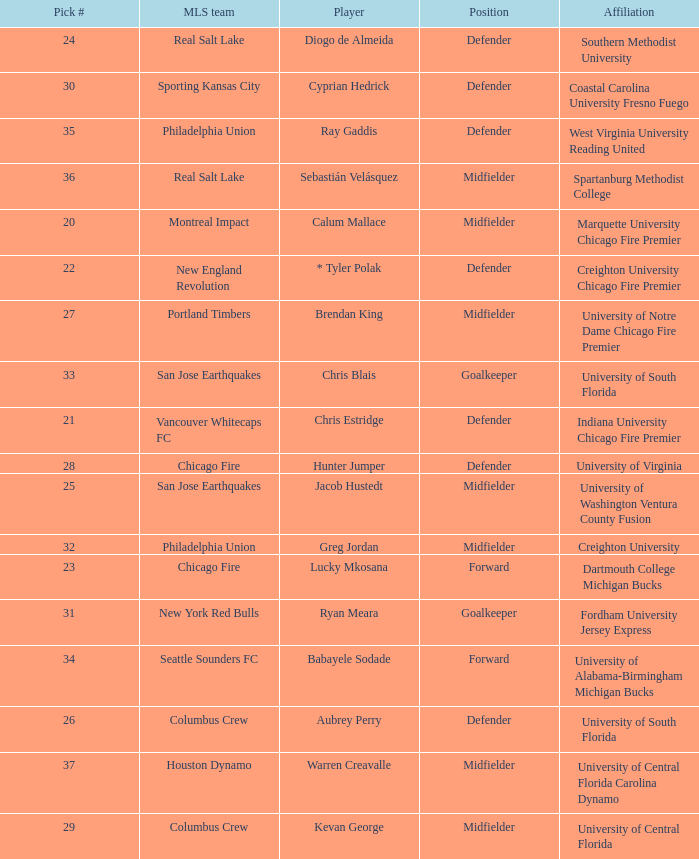What pick number did Real Salt Lake get? 24.0. Would you mind parsing the complete table? {'header': ['Pick #', 'MLS team', 'Player', 'Position', 'Affiliation'], 'rows': [['24', 'Real Salt Lake', 'Diogo de Almeida', 'Defender', 'Southern Methodist University'], ['30', 'Sporting Kansas City', 'Cyprian Hedrick', 'Defender', 'Coastal Carolina University Fresno Fuego'], ['35', 'Philadelphia Union', 'Ray Gaddis', 'Defender', 'West Virginia University Reading United'], ['36', 'Real Salt Lake', 'Sebastián Velásquez', 'Midfielder', 'Spartanburg Methodist College'], ['20', 'Montreal Impact', 'Calum Mallace', 'Midfielder', 'Marquette University Chicago Fire Premier'], ['22', 'New England Revolution', '* Tyler Polak', 'Defender', 'Creighton University Chicago Fire Premier'], ['27', 'Portland Timbers', 'Brendan King', 'Midfielder', 'University of Notre Dame Chicago Fire Premier'], ['33', 'San Jose Earthquakes', 'Chris Blais', 'Goalkeeper', 'University of South Florida'], ['21', 'Vancouver Whitecaps FC', 'Chris Estridge', 'Defender', 'Indiana University Chicago Fire Premier'], ['28', 'Chicago Fire', 'Hunter Jumper', 'Defender', 'University of Virginia'], ['25', 'San Jose Earthquakes', 'Jacob Hustedt', 'Midfielder', 'University of Washington Ventura County Fusion'], ['32', 'Philadelphia Union', 'Greg Jordan', 'Midfielder', 'Creighton University'], ['23', 'Chicago Fire', 'Lucky Mkosana', 'Forward', 'Dartmouth College Michigan Bucks'], ['31', 'New York Red Bulls', 'Ryan Meara', 'Goalkeeper', 'Fordham University Jersey Express'], ['34', 'Seattle Sounders FC', 'Babayele Sodade', 'Forward', 'University of Alabama-Birmingham Michigan Bucks'], ['26', 'Columbus Crew', 'Aubrey Perry', 'Defender', 'University of South Florida'], ['37', 'Houston Dynamo', 'Warren Creavalle', 'Midfielder', 'University of Central Florida Carolina Dynamo'], ['29', 'Columbus Crew', 'Kevan George', 'Midfielder', 'University of Central Florida']]} 